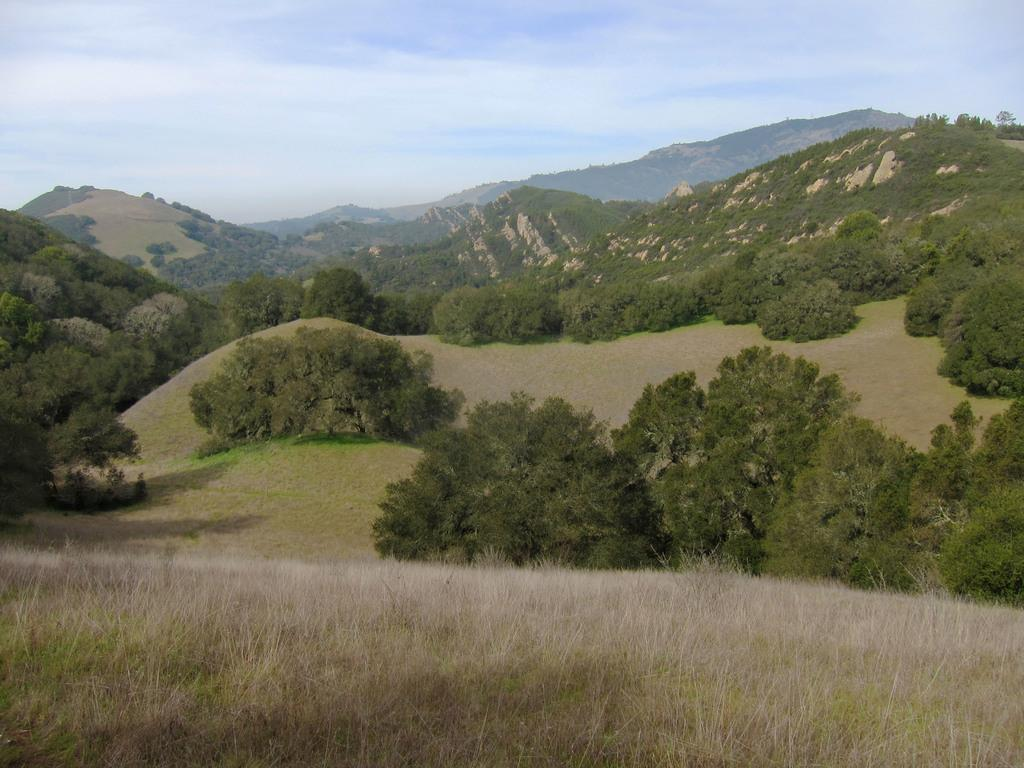What type of vegetation is present on the ground in the image? There is grass on the ground in the image. What other natural elements can be seen in the image? There are trees in the image. What is the color of the trees? The trees are green in color. What can be seen in the distance in the image? There are mountains visible in the background of the image. What else is visible in the background of the image? The sky is visible in the background of the image. How does the roof of the mountain look like in the image? There is no roof present in the image, as it features a natural landscape with mountains and trees. 